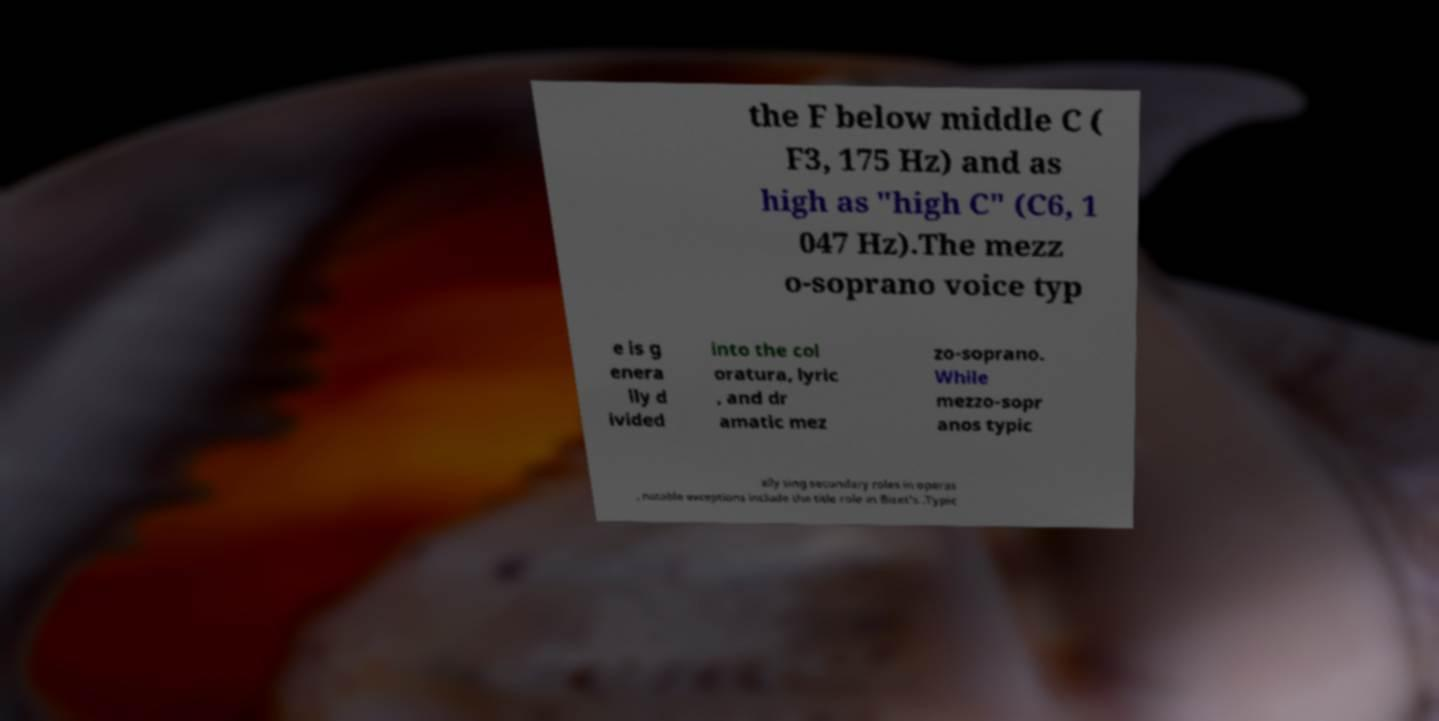What messages or text are displayed in this image? I need them in a readable, typed format. the F below middle C ( F3, 175 Hz) and as high as "high C" (C6, 1 047 Hz).The mezz o-soprano voice typ e is g enera lly d ivided into the col oratura, lyric , and dr amatic mez zo-soprano. While mezzo-sopr anos typic ally sing secondary roles in operas , notable exceptions include the title role in Bizet's .Typic 